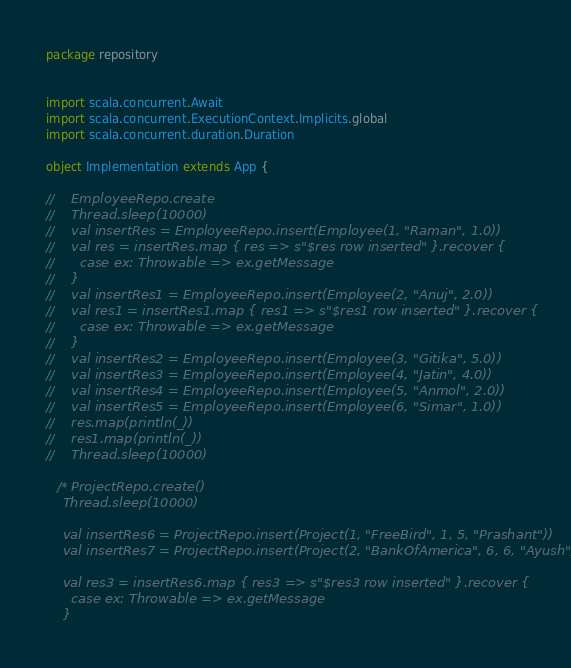<code> <loc_0><loc_0><loc_500><loc_500><_Scala_>package repository


import scala.concurrent.Await
import scala.concurrent.ExecutionContext.Implicits.global
import scala.concurrent.duration.Duration

object Implementation extends App {

//    EmployeeRepo.create
//    Thread.sleep(10000)
//    val insertRes = EmployeeRepo.insert(Employee(1, "Raman", 1.0))
//    val res = insertRes.map { res => s"$res row inserted" }.recover {
//      case ex: Throwable => ex.getMessage
//    }
//    val insertRes1 = EmployeeRepo.insert(Employee(2, "Anuj", 2.0))
//    val res1 = insertRes1.map { res1 => s"$res1 row inserted" }.recover {
//      case ex: Throwable => ex.getMessage
//    }
//    val insertRes2 = EmployeeRepo.insert(Employee(3, "Gitika", 5.0))
//    val insertRes3 = EmployeeRepo.insert(Employee(4, "Jatin", 4.0))
//    val insertRes4 = EmployeeRepo.insert(Employee(5, "Anmol", 2.0))
//    val insertRes5 = EmployeeRepo.insert(Employee(6, "Simar", 1.0))
//    res.map(println(_))
//    res1.map(println(_))
//    Thread.sleep(10000)

   /* ProjectRepo.create()
    Thread.sleep(10000)

    val insertRes6 = ProjectRepo.insert(Project(1, "FreeBird", 1, 5, "Prashant"))
    val insertRes7 = ProjectRepo.insert(Project(2, "BankOfAmerica", 6, 6, "Ayush"))

    val res3 = insertRes6.map { res3 => s"$res3 row inserted" }.recover {
      case ex: Throwable => ex.getMessage
    }
</code> 